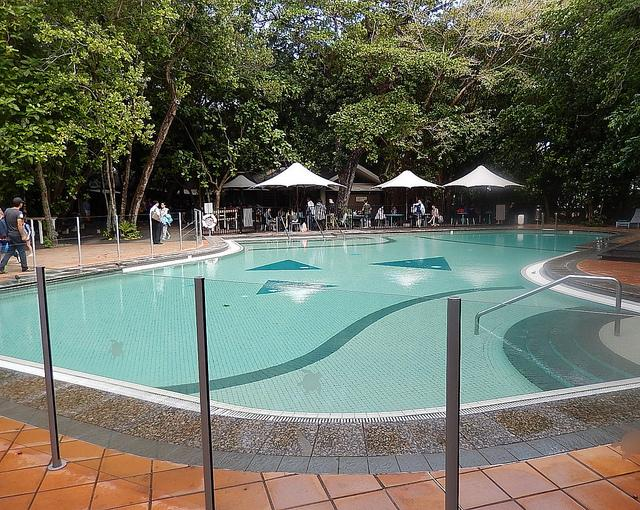What is the far end of the pool called? Please explain your reasoning. deep end. The water goes down further and it is kept to one end for safety 